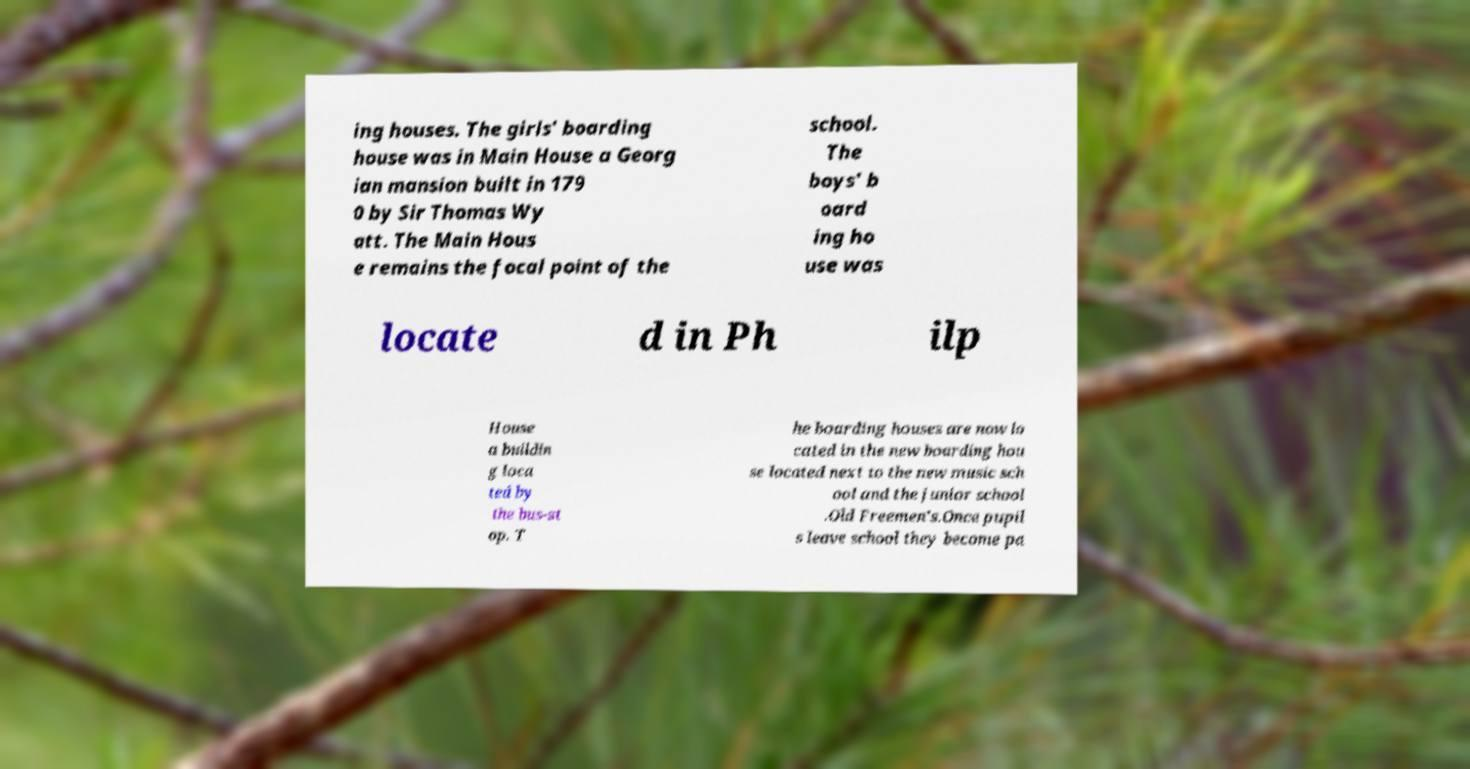Can you accurately transcribe the text from the provided image for me? ing houses. The girls' boarding house was in Main House a Georg ian mansion built in 179 0 by Sir Thomas Wy att. The Main Hous e remains the focal point of the school. The boys' b oard ing ho use was locate d in Ph ilp House a buildin g loca ted by the bus-st op. T he boarding houses are now lo cated in the new boarding hou se located next to the new music sch ool and the junior school .Old Freemen's.Once pupil s leave school they become pa 